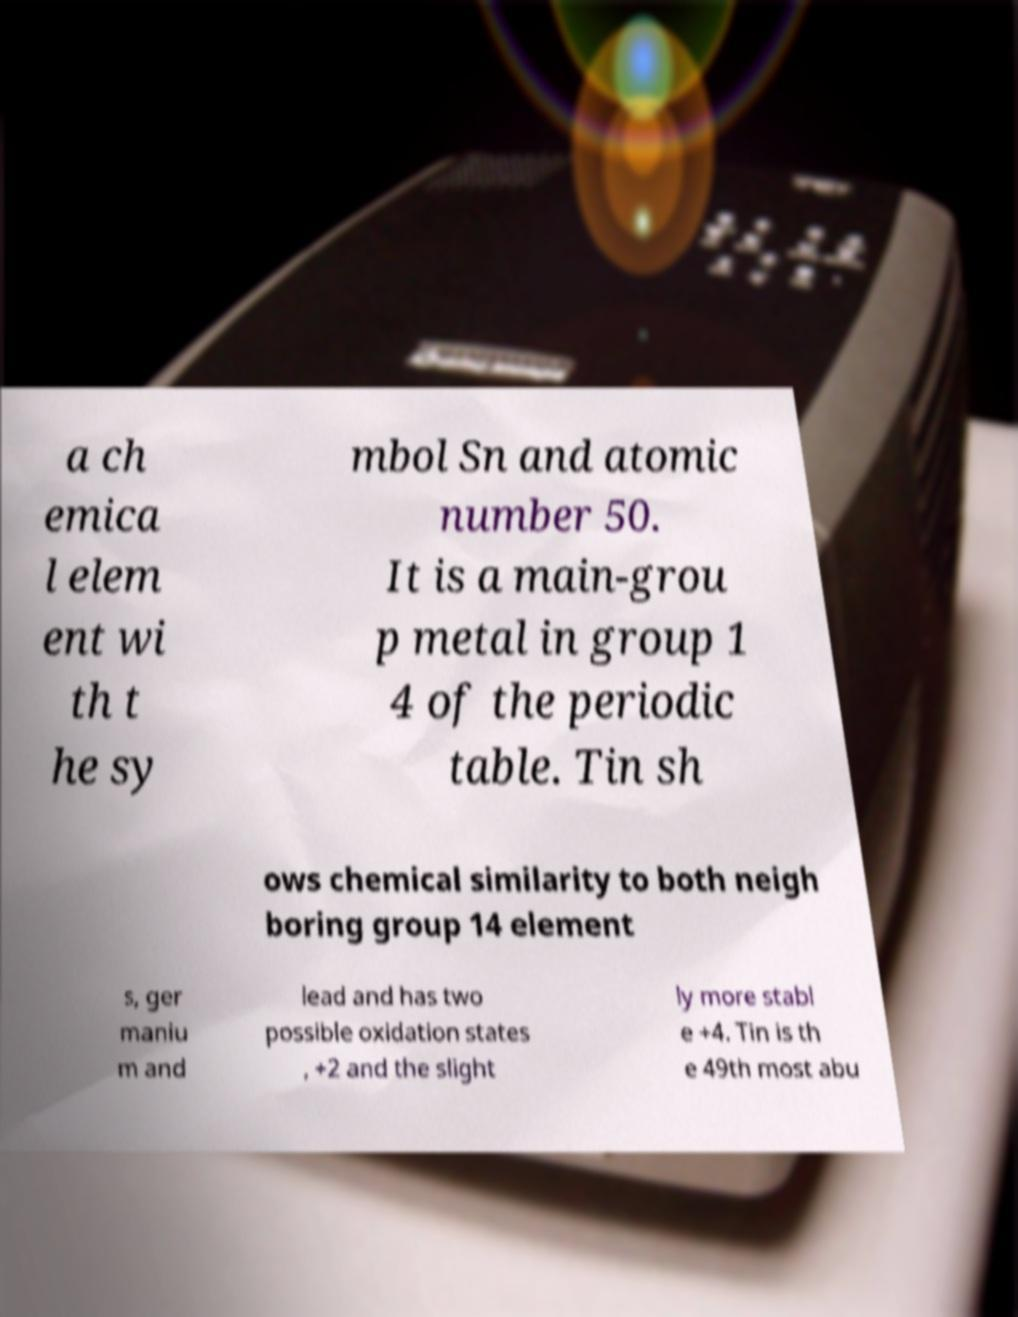Can you accurately transcribe the text from the provided image for me? a ch emica l elem ent wi th t he sy mbol Sn and atomic number 50. It is a main-grou p metal in group 1 4 of the periodic table. Tin sh ows chemical similarity to both neigh boring group 14 element s, ger maniu m and lead and has two possible oxidation states , +2 and the slight ly more stabl e +4. Tin is th e 49th most abu 